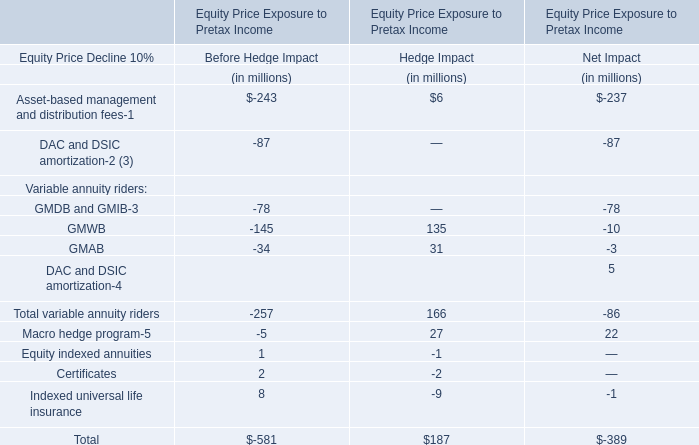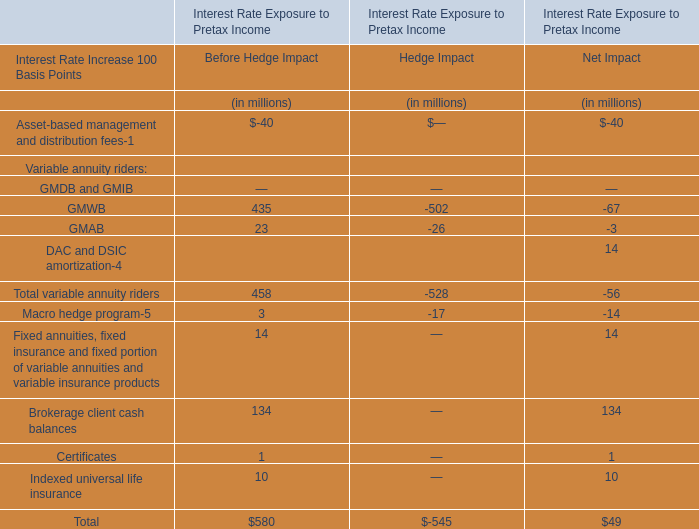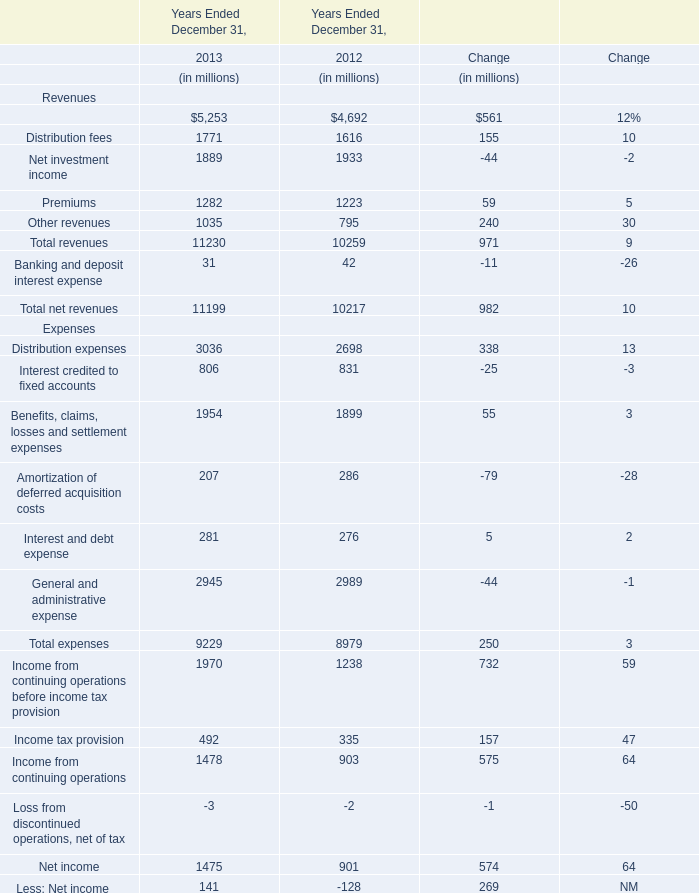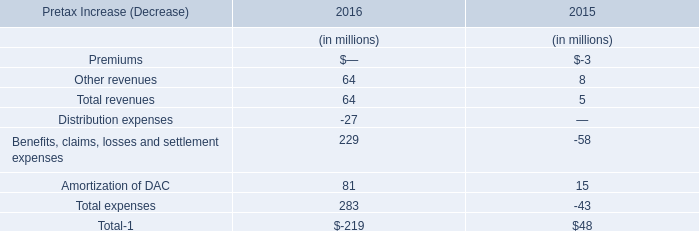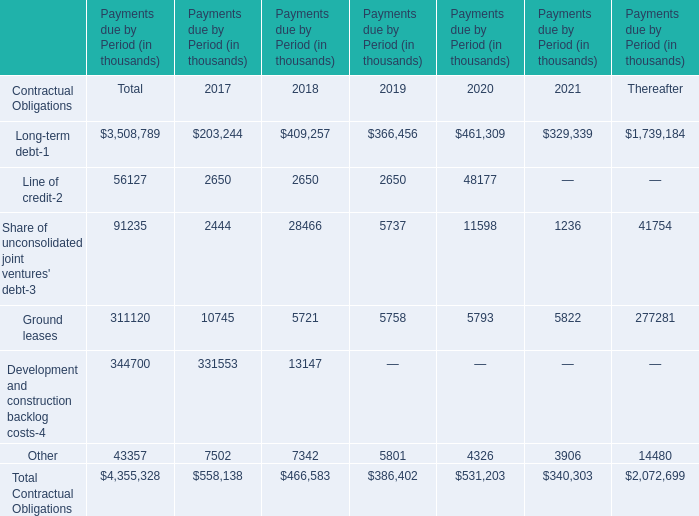In the year with largest amount of Long-term debt, what's the increasing rate of Ground leases? 
Computations: ((5793 - 5758) / 5758)
Answer: 0.00608. 